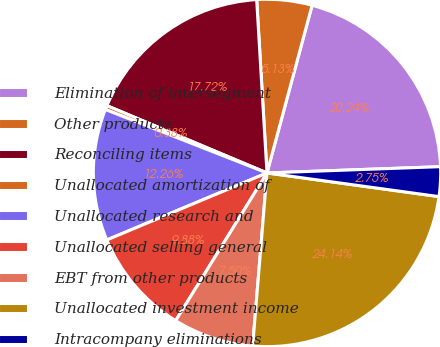Convert chart. <chart><loc_0><loc_0><loc_500><loc_500><pie_chart><fcel>Elimination of intersegment<fcel>Other products<fcel>Reconciling items<fcel>Unallocated amortization of<fcel>Unallocated research and<fcel>Unallocated selling general<fcel>EBT from other products<fcel>Unallocated investment income<fcel>Intracompany eliminations<nl><fcel>20.24%<fcel>5.13%<fcel>17.72%<fcel>0.38%<fcel>12.26%<fcel>9.88%<fcel>7.5%<fcel>24.14%<fcel>2.75%<nl></chart> 